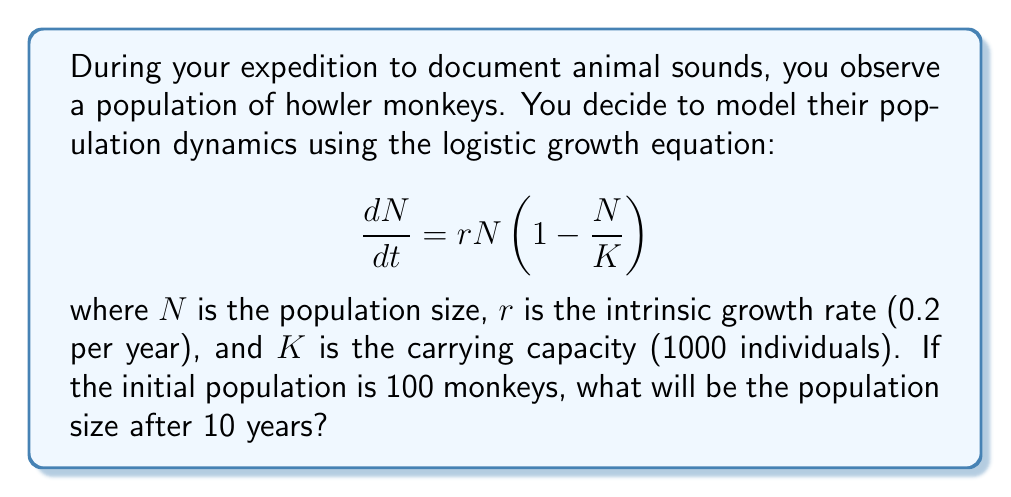Teach me how to tackle this problem. To solve this problem, we need to use the solution to the logistic growth equation:

$$N(t) = \frac{K}{1 + (\frac{K}{N_0} - 1)e^{-rt}}$$

Where:
$N(t)$ is the population size at time $t$
$K$ is the carrying capacity (1000)
$N_0$ is the initial population size (100)
$r$ is the intrinsic growth rate (0.2 per year)
$t$ is the time in years (10)

Let's substitute these values into the equation:

$$N(10) = \frac{1000}{1 + (\frac{1000}{100} - 1)e^{-0.2 * 10}}$$

$$N(10) = \frac{1000}{1 + (10 - 1)e^{-2}}$$

$$N(10) = \frac{1000}{1 + 9e^{-2}}$$

Using a calculator or computer:

$$e^{-2} \approx 0.1353$$

$$N(10) = \frac{1000}{1 + 9 * 0.1353} = \frac{1000}{2.2177}$$

$$N(10) \approx 450.92$$

Rounding to the nearest whole number, as we're dealing with a population of monkeys:

$$N(10) \approx 451$$
Answer: 451 monkeys 